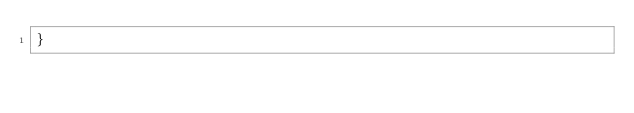<code> <loc_0><loc_0><loc_500><loc_500><_CSS_>}
</code> 